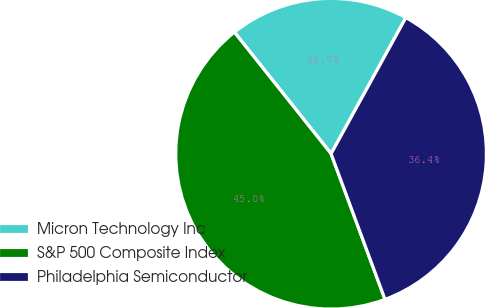Convert chart. <chart><loc_0><loc_0><loc_500><loc_500><pie_chart><fcel>Micron Technology Inc<fcel>S&P 500 Composite Index<fcel>Philadelphia Semiconductor<nl><fcel>18.69%<fcel>44.95%<fcel>36.36%<nl></chart> 